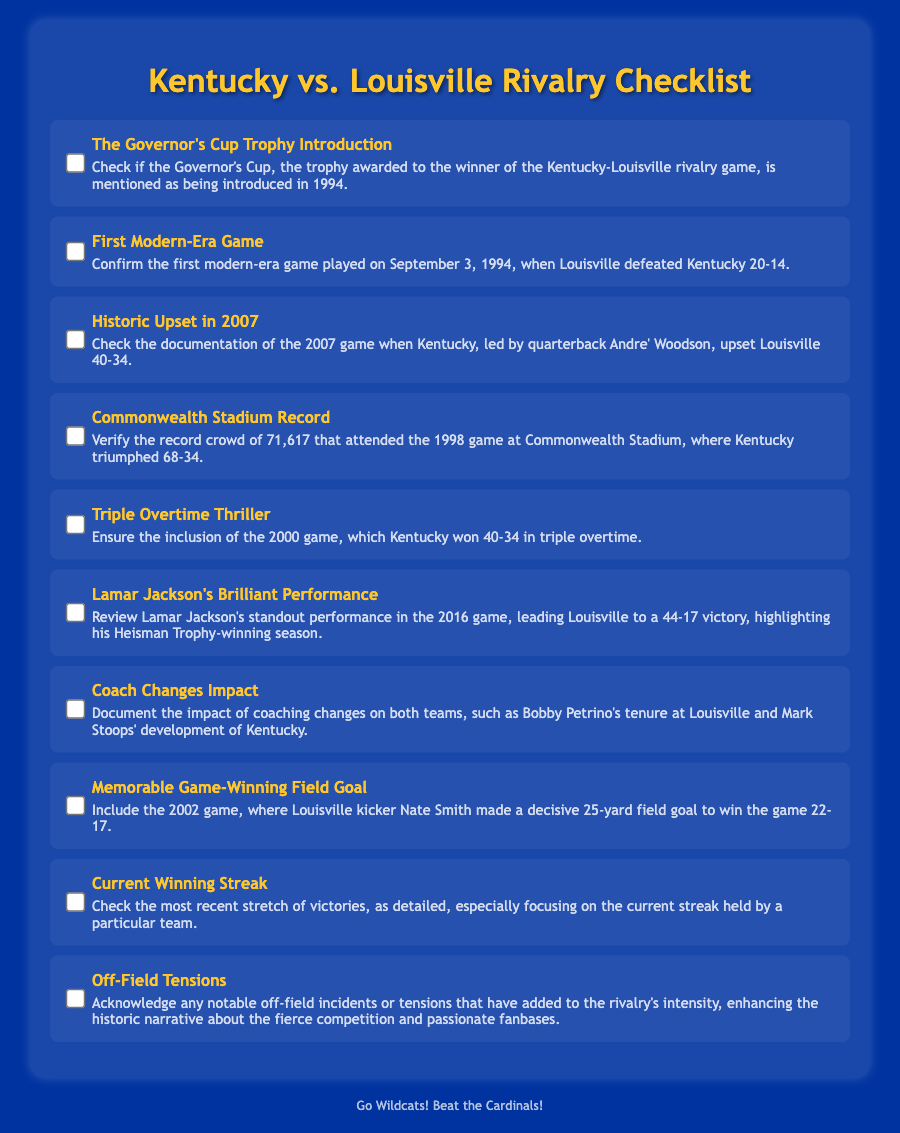What year was the Governor's Cup Trophy introduced? The introduction year of the Governor's Cup Trophy is mentioned in the document.
Answer: 1994 What was the score of the first modern-era game? The document provides the score of the first modern-era game played on September 3, 1994.
Answer: 20-14 Who led Kentucky during the historic upset in 2007? The quarterback leading Kentucky during the 2007 upset against Louisville is specified in the document.
Answer: Andre' Woodson What was the record attendance at Commonwealth Stadium in 1998? The document states the record crowd that attended the 1998 game at Commonwealth Stadium.
Answer: 71,617 How many overtimes were played in the 2000 game? The document details the number of overtimes in the 2000 game.
Answer: Triple What performance is highlighted from the 2016 game? The standout performance discussed in the document from the 2016 game relates to a specific player.
Answer: Lamar Jackson What was significant about the 2002 game-winning field goal? The document highlights a notable play that occurred at the end of the 2002 game.
Answer: 25-yard field goal What notable off-field tensions are acknowledged in the document? The document mentions the contributing factors to the rivalry's intensity.
Answer: Off-field incidents What coaching changes does the document mention? The document discusses impacts on both teams due to coaching changes.
Answer: Bobby Petrino’s tenure and Mark Stoops’ development 